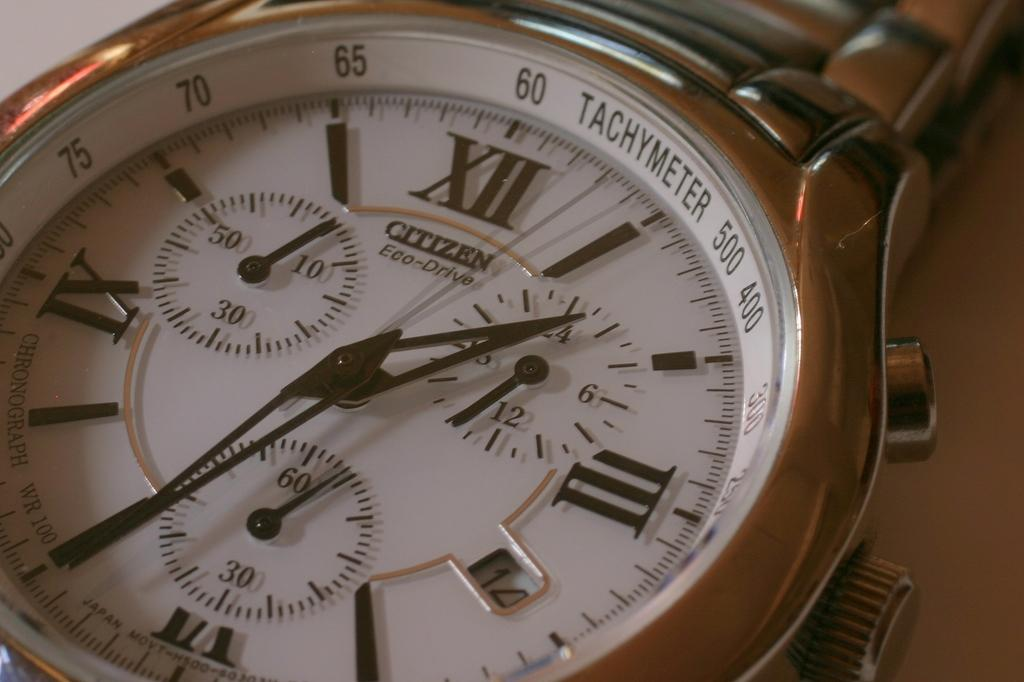<image>
Share a concise interpretation of the image provided. A roman numeral analog watch by Citizen also has a tachymeter. 